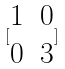<formula> <loc_0><loc_0><loc_500><loc_500>[ \begin{matrix} 1 & 0 \\ 0 & 3 \end{matrix} ]</formula> 